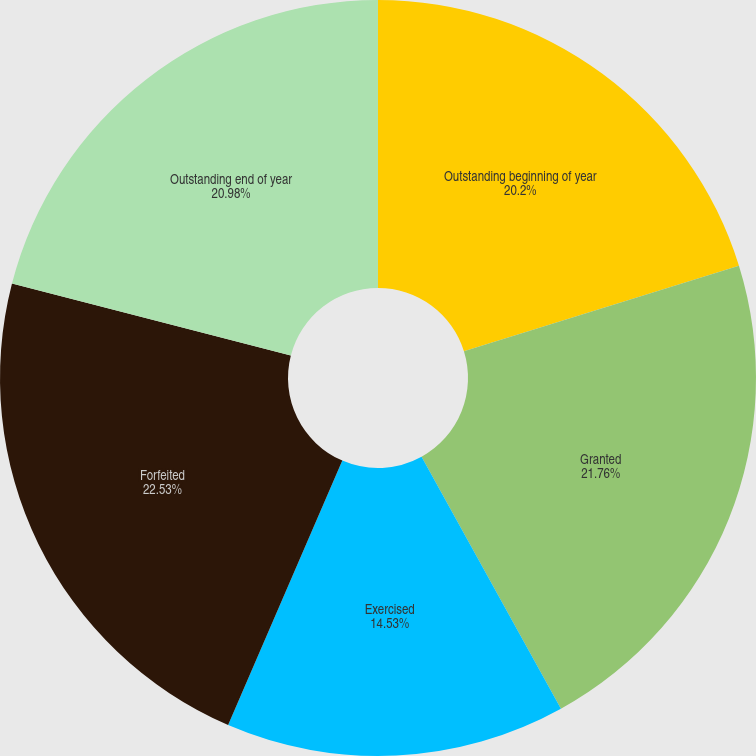Convert chart. <chart><loc_0><loc_0><loc_500><loc_500><pie_chart><fcel>Outstanding beginning of year<fcel>Granted<fcel>Exercised<fcel>Forfeited<fcel>Outstanding end of year<nl><fcel>20.2%<fcel>21.76%<fcel>14.53%<fcel>22.53%<fcel>20.98%<nl></chart> 